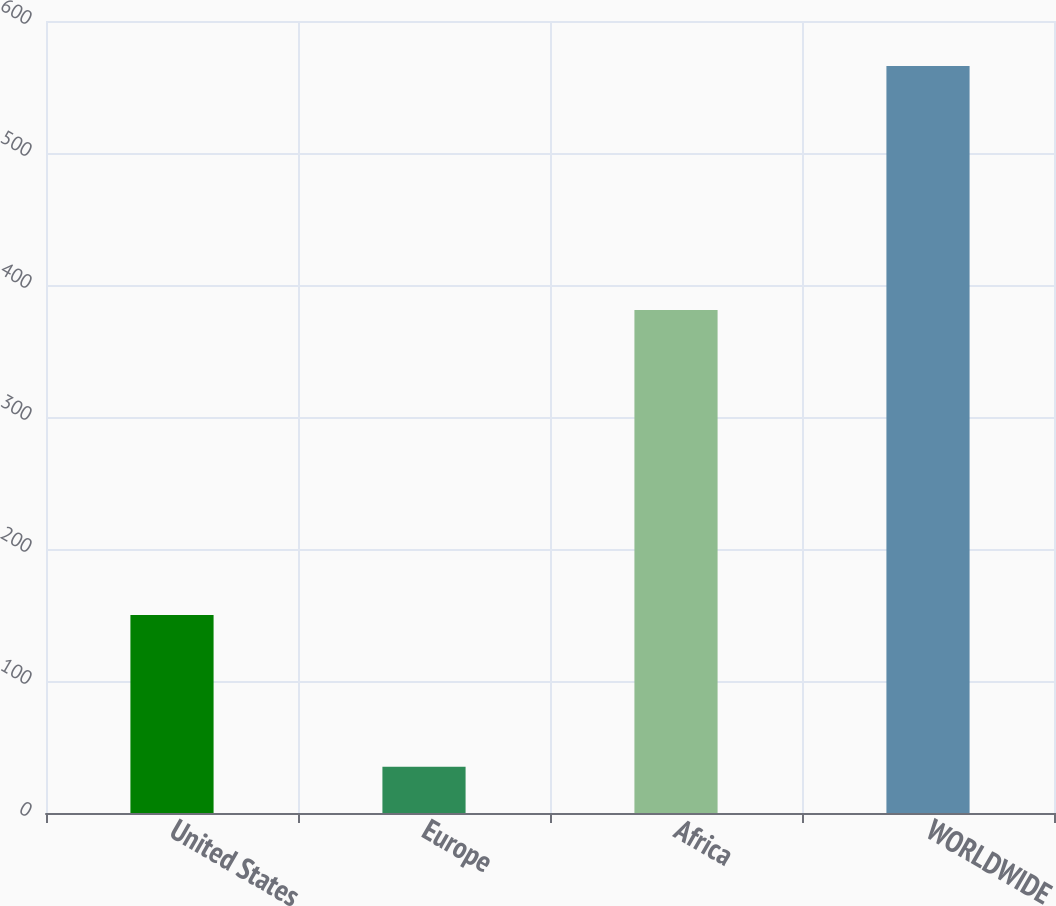<chart> <loc_0><loc_0><loc_500><loc_500><bar_chart><fcel>United States<fcel>Europe<fcel>Africa<fcel>WORLDWIDE<nl><fcel>150<fcel>35<fcel>381<fcel>566<nl></chart> 